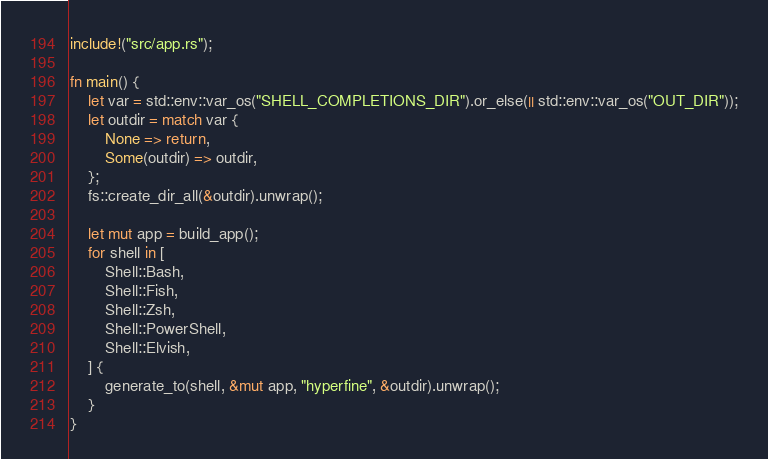<code> <loc_0><loc_0><loc_500><loc_500><_Rust_>
include!("src/app.rs");

fn main() {
    let var = std::env::var_os("SHELL_COMPLETIONS_DIR").or_else(|| std::env::var_os("OUT_DIR"));
    let outdir = match var {
        None => return,
        Some(outdir) => outdir,
    };
    fs::create_dir_all(&outdir).unwrap();

    let mut app = build_app();
    for shell in [
        Shell::Bash,
        Shell::Fish,
        Shell::Zsh,
        Shell::PowerShell,
        Shell::Elvish,
    ] {
        generate_to(shell, &mut app, "hyperfine", &outdir).unwrap();
    }
}
</code> 